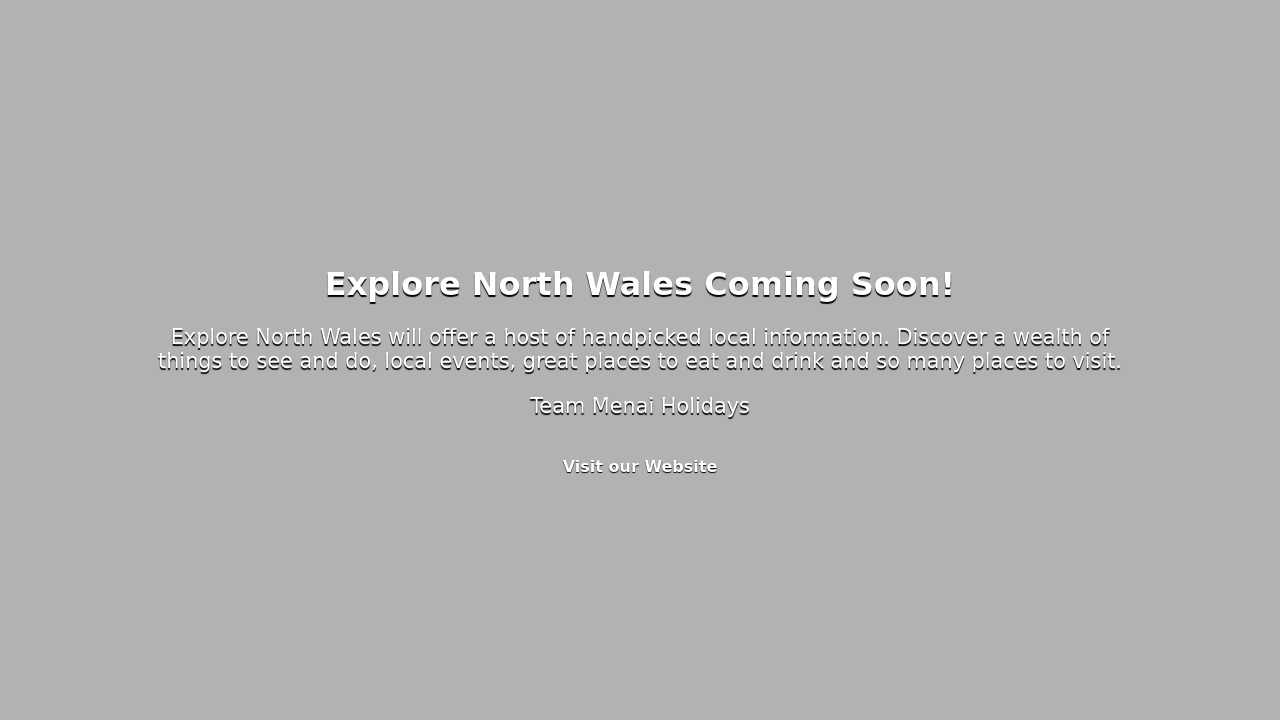What are some key elements that should be included on a website about exploring North Wales? A website dedicated to exploring North Wales should include interactive maps that highlight key attractions, an event calendar with local happenings, and detailed travel guides for various regions. Include testimonials or stories from travelers, a gallery showcasing the beauty of North Wales, and practical information like transportation options. Don't forget to add a blog to share the latest news, trip itineraries, and recommendations for accommodations and dining. Making sure the website is easily navigable and engaging will inspire visitors to explore what North Wales has to offer. 